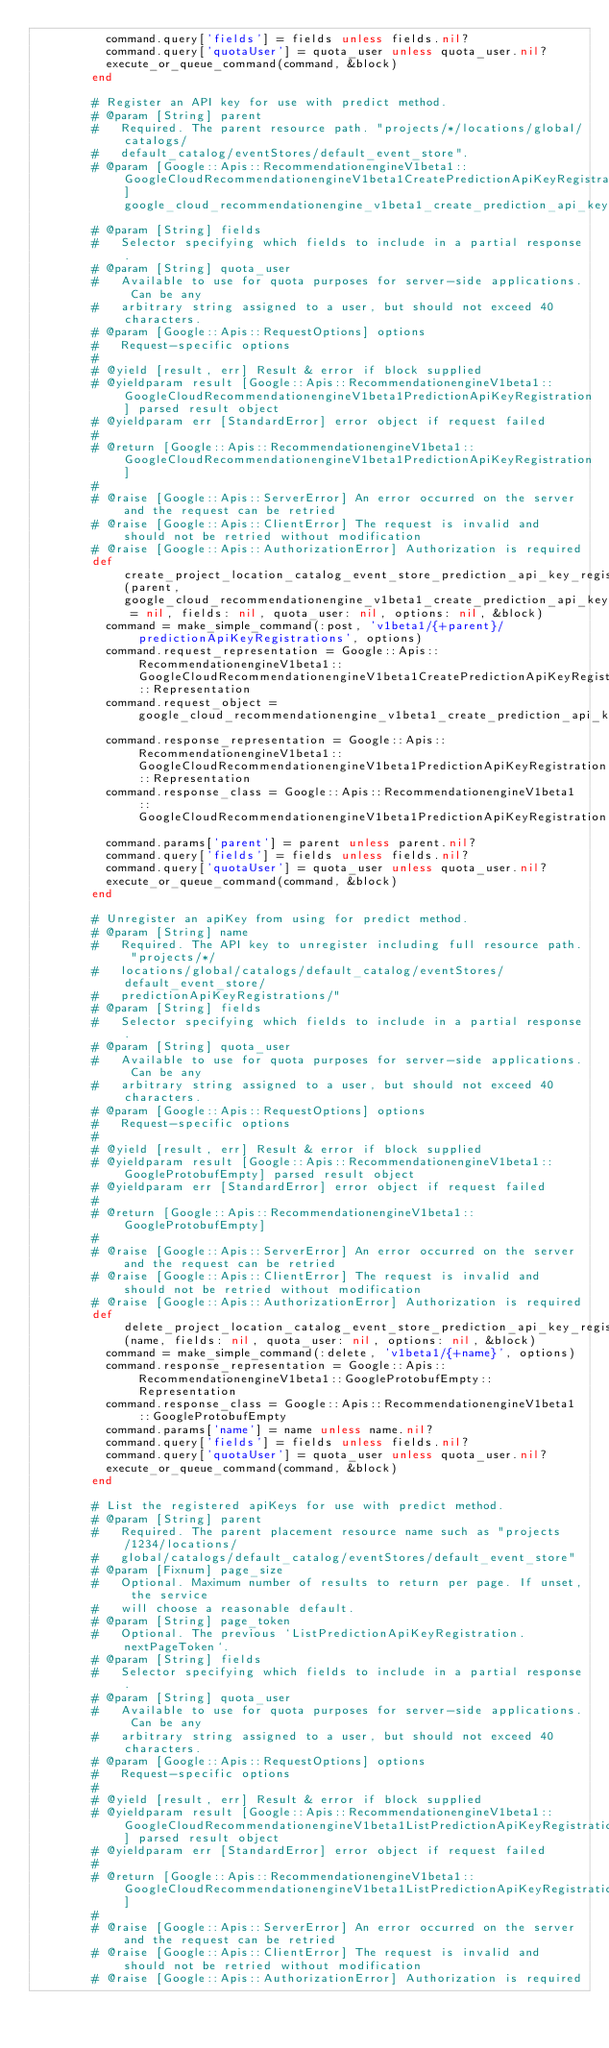Convert code to text. <code><loc_0><loc_0><loc_500><loc_500><_Ruby_>          command.query['fields'] = fields unless fields.nil?
          command.query['quotaUser'] = quota_user unless quota_user.nil?
          execute_or_queue_command(command, &block)
        end
        
        # Register an API key for use with predict method.
        # @param [String] parent
        #   Required. The parent resource path. "projects/*/locations/global/catalogs/
        #   default_catalog/eventStores/default_event_store".
        # @param [Google::Apis::RecommendationengineV1beta1::GoogleCloudRecommendationengineV1beta1CreatePredictionApiKeyRegistrationRequest] google_cloud_recommendationengine_v1beta1_create_prediction_api_key_registration_request_object
        # @param [String] fields
        #   Selector specifying which fields to include in a partial response.
        # @param [String] quota_user
        #   Available to use for quota purposes for server-side applications. Can be any
        #   arbitrary string assigned to a user, but should not exceed 40 characters.
        # @param [Google::Apis::RequestOptions] options
        #   Request-specific options
        #
        # @yield [result, err] Result & error if block supplied
        # @yieldparam result [Google::Apis::RecommendationengineV1beta1::GoogleCloudRecommendationengineV1beta1PredictionApiKeyRegistration] parsed result object
        # @yieldparam err [StandardError] error object if request failed
        #
        # @return [Google::Apis::RecommendationengineV1beta1::GoogleCloudRecommendationengineV1beta1PredictionApiKeyRegistration]
        #
        # @raise [Google::Apis::ServerError] An error occurred on the server and the request can be retried
        # @raise [Google::Apis::ClientError] The request is invalid and should not be retried without modification
        # @raise [Google::Apis::AuthorizationError] Authorization is required
        def create_project_location_catalog_event_store_prediction_api_key_registration(parent, google_cloud_recommendationengine_v1beta1_create_prediction_api_key_registration_request_object = nil, fields: nil, quota_user: nil, options: nil, &block)
          command = make_simple_command(:post, 'v1beta1/{+parent}/predictionApiKeyRegistrations', options)
          command.request_representation = Google::Apis::RecommendationengineV1beta1::GoogleCloudRecommendationengineV1beta1CreatePredictionApiKeyRegistrationRequest::Representation
          command.request_object = google_cloud_recommendationengine_v1beta1_create_prediction_api_key_registration_request_object
          command.response_representation = Google::Apis::RecommendationengineV1beta1::GoogleCloudRecommendationengineV1beta1PredictionApiKeyRegistration::Representation
          command.response_class = Google::Apis::RecommendationengineV1beta1::GoogleCloudRecommendationengineV1beta1PredictionApiKeyRegistration
          command.params['parent'] = parent unless parent.nil?
          command.query['fields'] = fields unless fields.nil?
          command.query['quotaUser'] = quota_user unless quota_user.nil?
          execute_or_queue_command(command, &block)
        end
        
        # Unregister an apiKey from using for predict method.
        # @param [String] name
        #   Required. The API key to unregister including full resource path. "projects/*/
        #   locations/global/catalogs/default_catalog/eventStores/default_event_store/
        #   predictionApiKeyRegistrations/"
        # @param [String] fields
        #   Selector specifying which fields to include in a partial response.
        # @param [String] quota_user
        #   Available to use for quota purposes for server-side applications. Can be any
        #   arbitrary string assigned to a user, but should not exceed 40 characters.
        # @param [Google::Apis::RequestOptions] options
        #   Request-specific options
        #
        # @yield [result, err] Result & error if block supplied
        # @yieldparam result [Google::Apis::RecommendationengineV1beta1::GoogleProtobufEmpty] parsed result object
        # @yieldparam err [StandardError] error object if request failed
        #
        # @return [Google::Apis::RecommendationengineV1beta1::GoogleProtobufEmpty]
        #
        # @raise [Google::Apis::ServerError] An error occurred on the server and the request can be retried
        # @raise [Google::Apis::ClientError] The request is invalid and should not be retried without modification
        # @raise [Google::Apis::AuthorizationError] Authorization is required
        def delete_project_location_catalog_event_store_prediction_api_key_registration(name, fields: nil, quota_user: nil, options: nil, &block)
          command = make_simple_command(:delete, 'v1beta1/{+name}', options)
          command.response_representation = Google::Apis::RecommendationengineV1beta1::GoogleProtobufEmpty::Representation
          command.response_class = Google::Apis::RecommendationengineV1beta1::GoogleProtobufEmpty
          command.params['name'] = name unless name.nil?
          command.query['fields'] = fields unless fields.nil?
          command.query['quotaUser'] = quota_user unless quota_user.nil?
          execute_or_queue_command(command, &block)
        end
        
        # List the registered apiKeys for use with predict method.
        # @param [String] parent
        #   Required. The parent placement resource name such as "projects/1234/locations/
        #   global/catalogs/default_catalog/eventStores/default_event_store"
        # @param [Fixnum] page_size
        #   Optional. Maximum number of results to return per page. If unset, the service
        #   will choose a reasonable default.
        # @param [String] page_token
        #   Optional. The previous `ListPredictionApiKeyRegistration.nextPageToken`.
        # @param [String] fields
        #   Selector specifying which fields to include in a partial response.
        # @param [String] quota_user
        #   Available to use for quota purposes for server-side applications. Can be any
        #   arbitrary string assigned to a user, but should not exceed 40 characters.
        # @param [Google::Apis::RequestOptions] options
        #   Request-specific options
        #
        # @yield [result, err] Result & error if block supplied
        # @yieldparam result [Google::Apis::RecommendationengineV1beta1::GoogleCloudRecommendationengineV1beta1ListPredictionApiKeyRegistrationsResponse] parsed result object
        # @yieldparam err [StandardError] error object if request failed
        #
        # @return [Google::Apis::RecommendationengineV1beta1::GoogleCloudRecommendationengineV1beta1ListPredictionApiKeyRegistrationsResponse]
        #
        # @raise [Google::Apis::ServerError] An error occurred on the server and the request can be retried
        # @raise [Google::Apis::ClientError] The request is invalid and should not be retried without modification
        # @raise [Google::Apis::AuthorizationError] Authorization is required</code> 